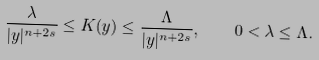<formula> <loc_0><loc_0><loc_500><loc_500>\frac { \lambda } { | y | ^ { n + 2 s } } \leq K ( y ) \leq \frac { \Lambda } { | y | ^ { n + 2 s } } , \quad 0 < \lambda \leq \Lambda .</formula> 